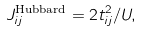<formula> <loc_0><loc_0><loc_500><loc_500>J _ { i j } ^ { \text {Hubbard} } = 2 t _ { i j } ^ { 2 } / U ,</formula> 